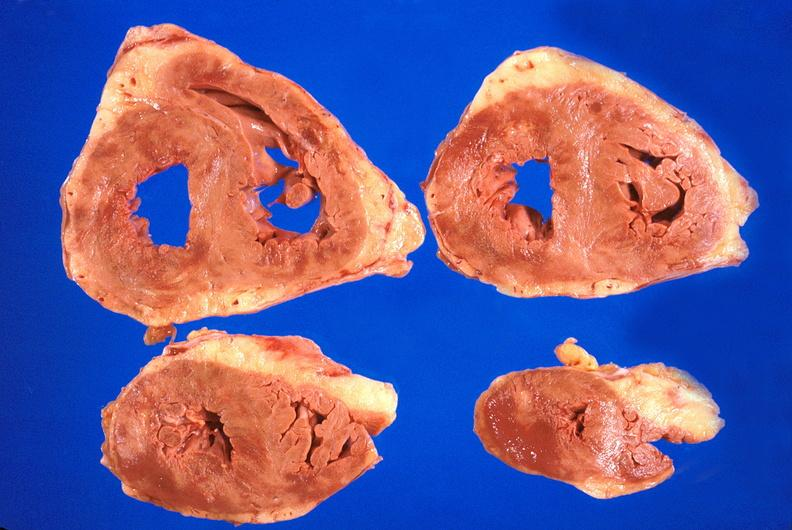where is this?
Answer the question using a single word or phrase. Heart 